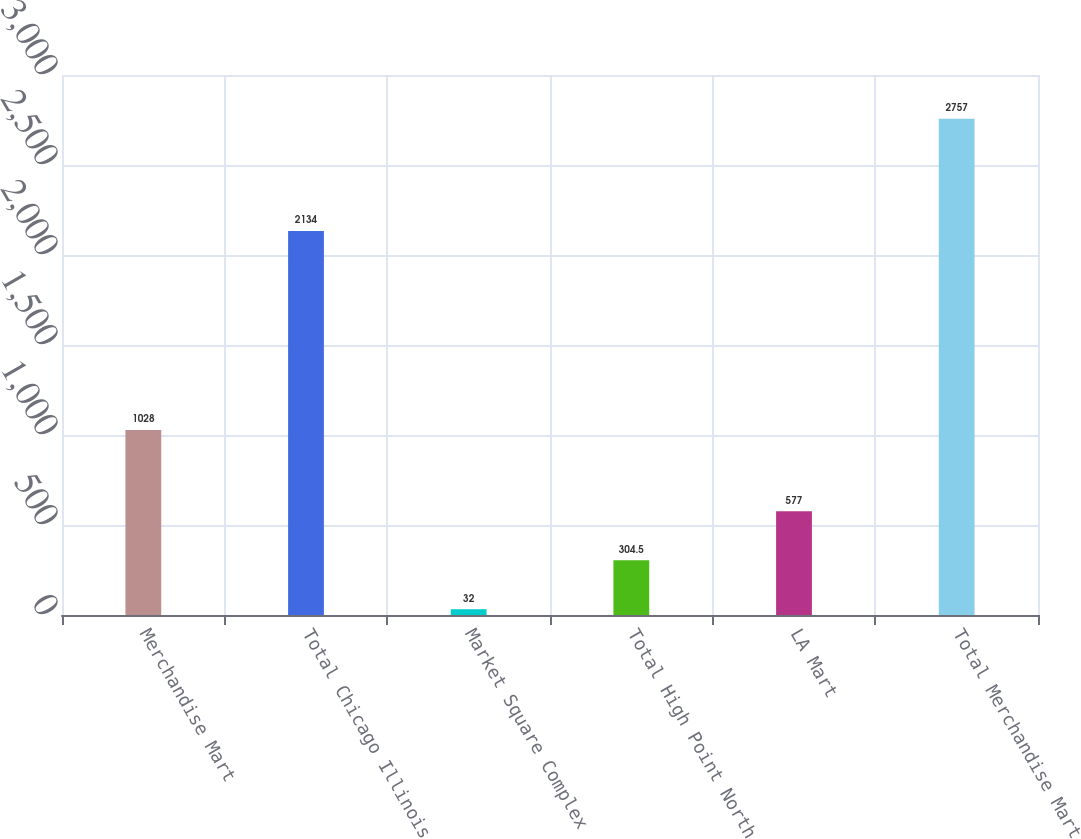Convert chart to OTSL. <chart><loc_0><loc_0><loc_500><loc_500><bar_chart><fcel>Merchandise Mart<fcel>Total Chicago Illinois<fcel>Market Square Complex<fcel>Total High Point North<fcel>LA Mart<fcel>Total Merchandise Mart<nl><fcel>1028<fcel>2134<fcel>32<fcel>304.5<fcel>577<fcel>2757<nl></chart> 